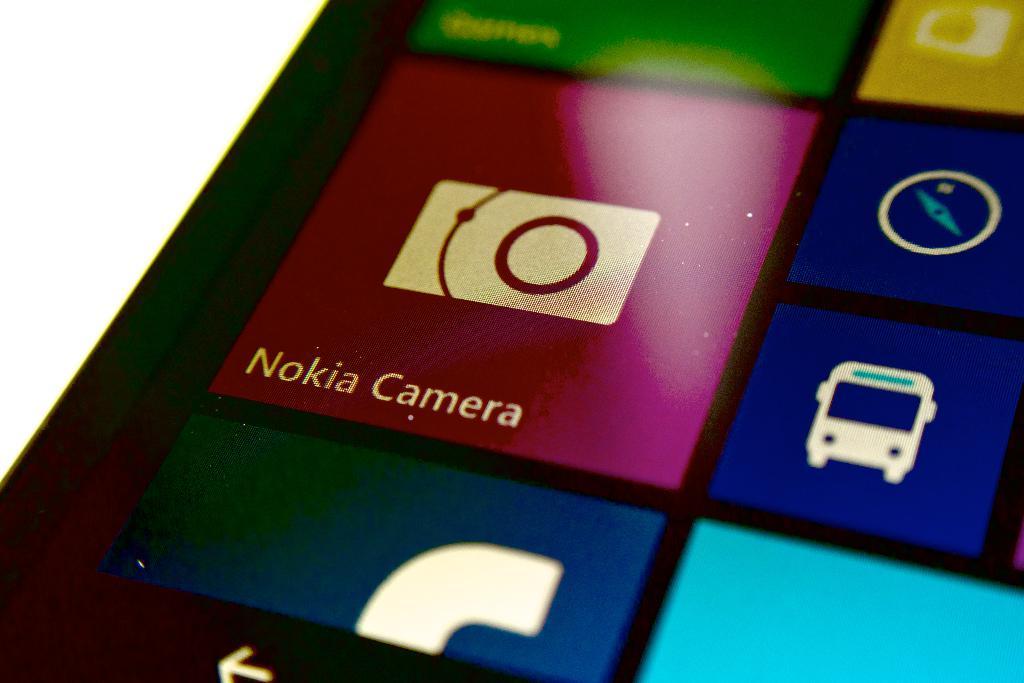What is the sing under the camara bottom?
Provide a short and direct response. Nokia camera. What kind of camera/?
Provide a succinct answer. Nokia. 